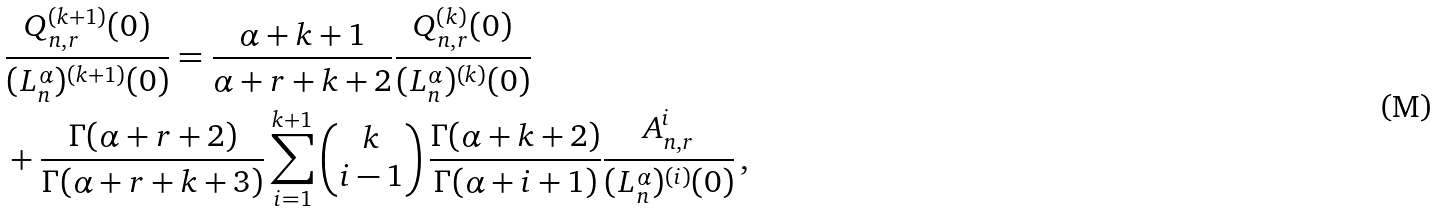<formula> <loc_0><loc_0><loc_500><loc_500>& \frac { Q _ { n , r } ^ { ( k + 1 ) } ( 0 ) } { ( L _ { n } ^ { \alpha } ) ^ { ( k + 1 ) } ( 0 ) } = \frac { \alpha + k + 1 } { \alpha + r + k + 2 } \frac { Q _ { n , r } ^ { ( k ) } ( 0 ) } { ( L _ { n } ^ { \alpha } ) ^ { ( k ) } ( 0 ) } \\ & + \frac { \Gamma ( \alpha + r + 2 ) } { \Gamma ( \alpha + r + k + 3 ) } \sum _ { i = 1 } ^ { k + 1 } \left ( \begin{matrix} k \\ i - 1 \end{matrix} \right ) \frac { \Gamma ( \alpha + k + 2 ) } { \Gamma ( \alpha + i + 1 ) } \frac { A _ { n , r } ^ { i } } { ( L _ { n } ^ { \alpha } ) ^ { ( i ) } ( 0 ) } \, ,</formula> 